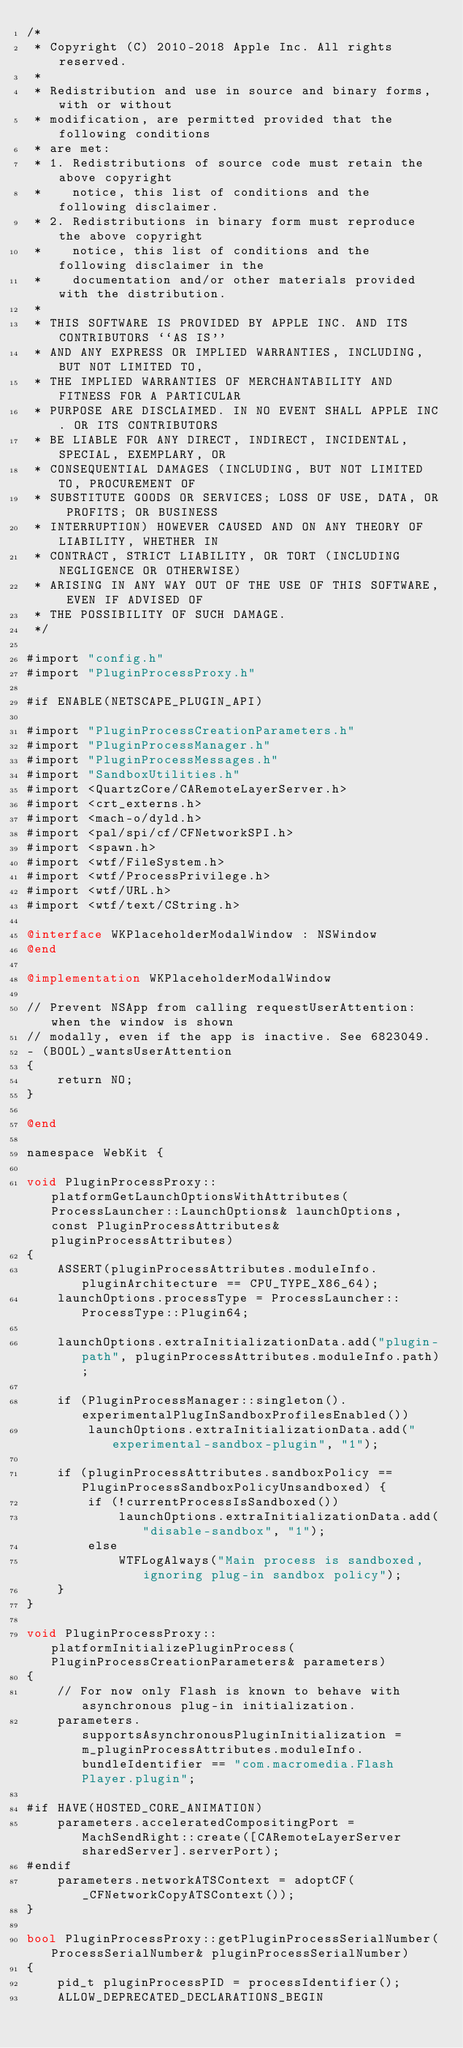Convert code to text. <code><loc_0><loc_0><loc_500><loc_500><_ObjectiveC_>/*
 * Copyright (C) 2010-2018 Apple Inc. All rights reserved.
 *
 * Redistribution and use in source and binary forms, with or without
 * modification, are permitted provided that the following conditions
 * are met:
 * 1. Redistributions of source code must retain the above copyright
 *    notice, this list of conditions and the following disclaimer.
 * 2. Redistributions in binary form must reproduce the above copyright
 *    notice, this list of conditions and the following disclaimer in the
 *    documentation and/or other materials provided with the distribution.
 *
 * THIS SOFTWARE IS PROVIDED BY APPLE INC. AND ITS CONTRIBUTORS ``AS IS''
 * AND ANY EXPRESS OR IMPLIED WARRANTIES, INCLUDING, BUT NOT LIMITED TO,
 * THE IMPLIED WARRANTIES OF MERCHANTABILITY AND FITNESS FOR A PARTICULAR
 * PURPOSE ARE DISCLAIMED. IN NO EVENT SHALL APPLE INC. OR ITS CONTRIBUTORS
 * BE LIABLE FOR ANY DIRECT, INDIRECT, INCIDENTAL, SPECIAL, EXEMPLARY, OR
 * CONSEQUENTIAL DAMAGES (INCLUDING, BUT NOT LIMITED TO, PROCUREMENT OF
 * SUBSTITUTE GOODS OR SERVICES; LOSS OF USE, DATA, OR PROFITS; OR BUSINESS
 * INTERRUPTION) HOWEVER CAUSED AND ON ANY THEORY OF LIABILITY, WHETHER IN
 * CONTRACT, STRICT LIABILITY, OR TORT (INCLUDING NEGLIGENCE OR OTHERWISE)
 * ARISING IN ANY WAY OUT OF THE USE OF THIS SOFTWARE, EVEN IF ADVISED OF
 * THE POSSIBILITY OF SUCH DAMAGE.
 */

#import "config.h"
#import "PluginProcessProxy.h"

#if ENABLE(NETSCAPE_PLUGIN_API)

#import "PluginProcessCreationParameters.h"
#import "PluginProcessManager.h"
#import "PluginProcessMessages.h"
#import "SandboxUtilities.h"
#import <QuartzCore/CARemoteLayerServer.h>
#import <crt_externs.h>
#import <mach-o/dyld.h>
#import <pal/spi/cf/CFNetworkSPI.h>
#import <spawn.h>
#import <wtf/FileSystem.h>
#import <wtf/ProcessPrivilege.h>
#import <wtf/URL.h>
#import <wtf/text/CString.h>

@interface WKPlaceholderModalWindow : NSWindow 
@end

@implementation WKPlaceholderModalWindow

// Prevent NSApp from calling requestUserAttention: when the window is shown 
// modally, even if the app is inactive. See 6823049.
- (BOOL)_wantsUserAttention
{
    return NO;   
}

@end

namespace WebKit {
    
void PluginProcessProxy::platformGetLaunchOptionsWithAttributes(ProcessLauncher::LaunchOptions& launchOptions, const PluginProcessAttributes& pluginProcessAttributes)
{
    ASSERT(pluginProcessAttributes.moduleInfo.pluginArchitecture == CPU_TYPE_X86_64);
    launchOptions.processType = ProcessLauncher::ProcessType::Plugin64;

    launchOptions.extraInitializationData.add("plugin-path", pluginProcessAttributes.moduleInfo.path);

    if (PluginProcessManager::singleton().experimentalPlugInSandboxProfilesEnabled())
        launchOptions.extraInitializationData.add("experimental-sandbox-plugin", "1");

    if (pluginProcessAttributes.sandboxPolicy == PluginProcessSandboxPolicyUnsandboxed) {
        if (!currentProcessIsSandboxed())
            launchOptions.extraInitializationData.add("disable-sandbox", "1");
        else
            WTFLogAlways("Main process is sandboxed, ignoring plug-in sandbox policy");
    }
}

void PluginProcessProxy::platformInitializePluginProcess(PluginProcessCreationParameters& parameters)
{
    // For now only Flash is known to behave with asynchronous plug-in initialization.
    parameters.supportsAsynchronousPluginInitialization = m_pluginProcessAttributes.moduleInfo.bundleIdentifier == "com.macromedia.Flash Player.plugin";

#if HAVE(HOSTED_CORE_ANIMATION)
    parameters.acceleratedCompositingPort = MachSendRight::create([CARemoteLayerServer sharedServer].serverPort);
#endif
    parameters.networkATSContext = adoptCF(_CFNetworkCopyATSContext());
}

bool PluginProcessProxy::getPluginProcessSerialNumber(ProcessSerialNumber& pluginProcessSerialNumber)
{
    pid_t pluginProcessPID = processIdentifier();
    ALLOW_DEPRECATED_DECLARATIONS_BEGIN</code> 